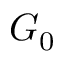Convert formula to latex. <formula><loc_0><loc_0><loc_500><loc_500>G _ { 0 }</formula> 